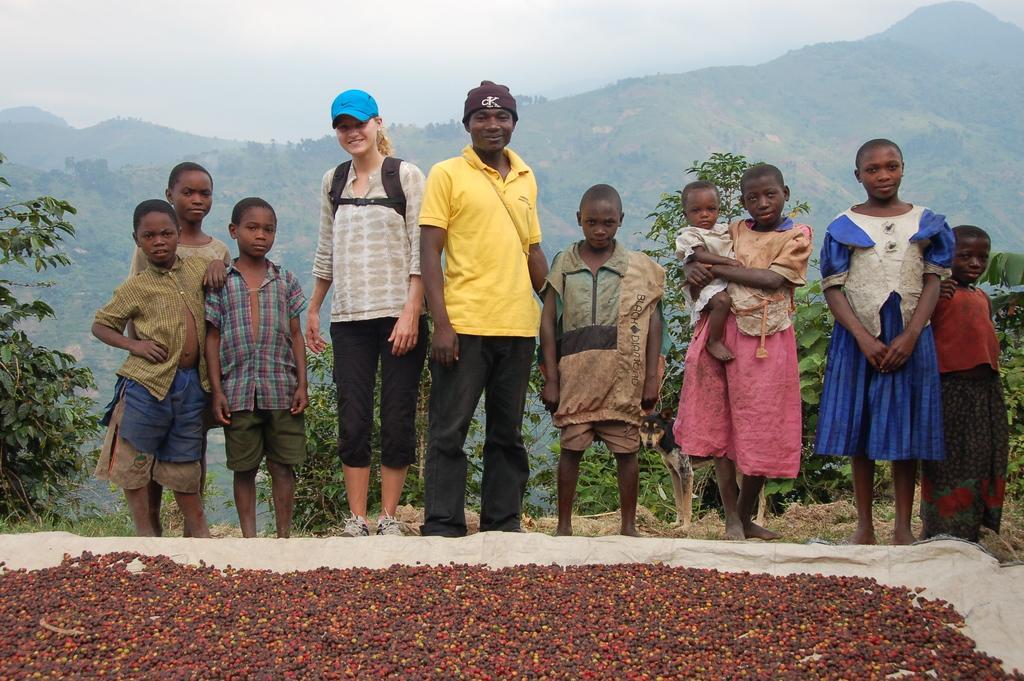Can you describe this image briefly? In this picture I can see a woman, a man and few children standing in front and I see that few of them are smiling. In front of them, I can see a cream color thing and on it I see number of red and black color things. Behind them I can see few plants. In the background I can see the sky and I can also see the hills. 